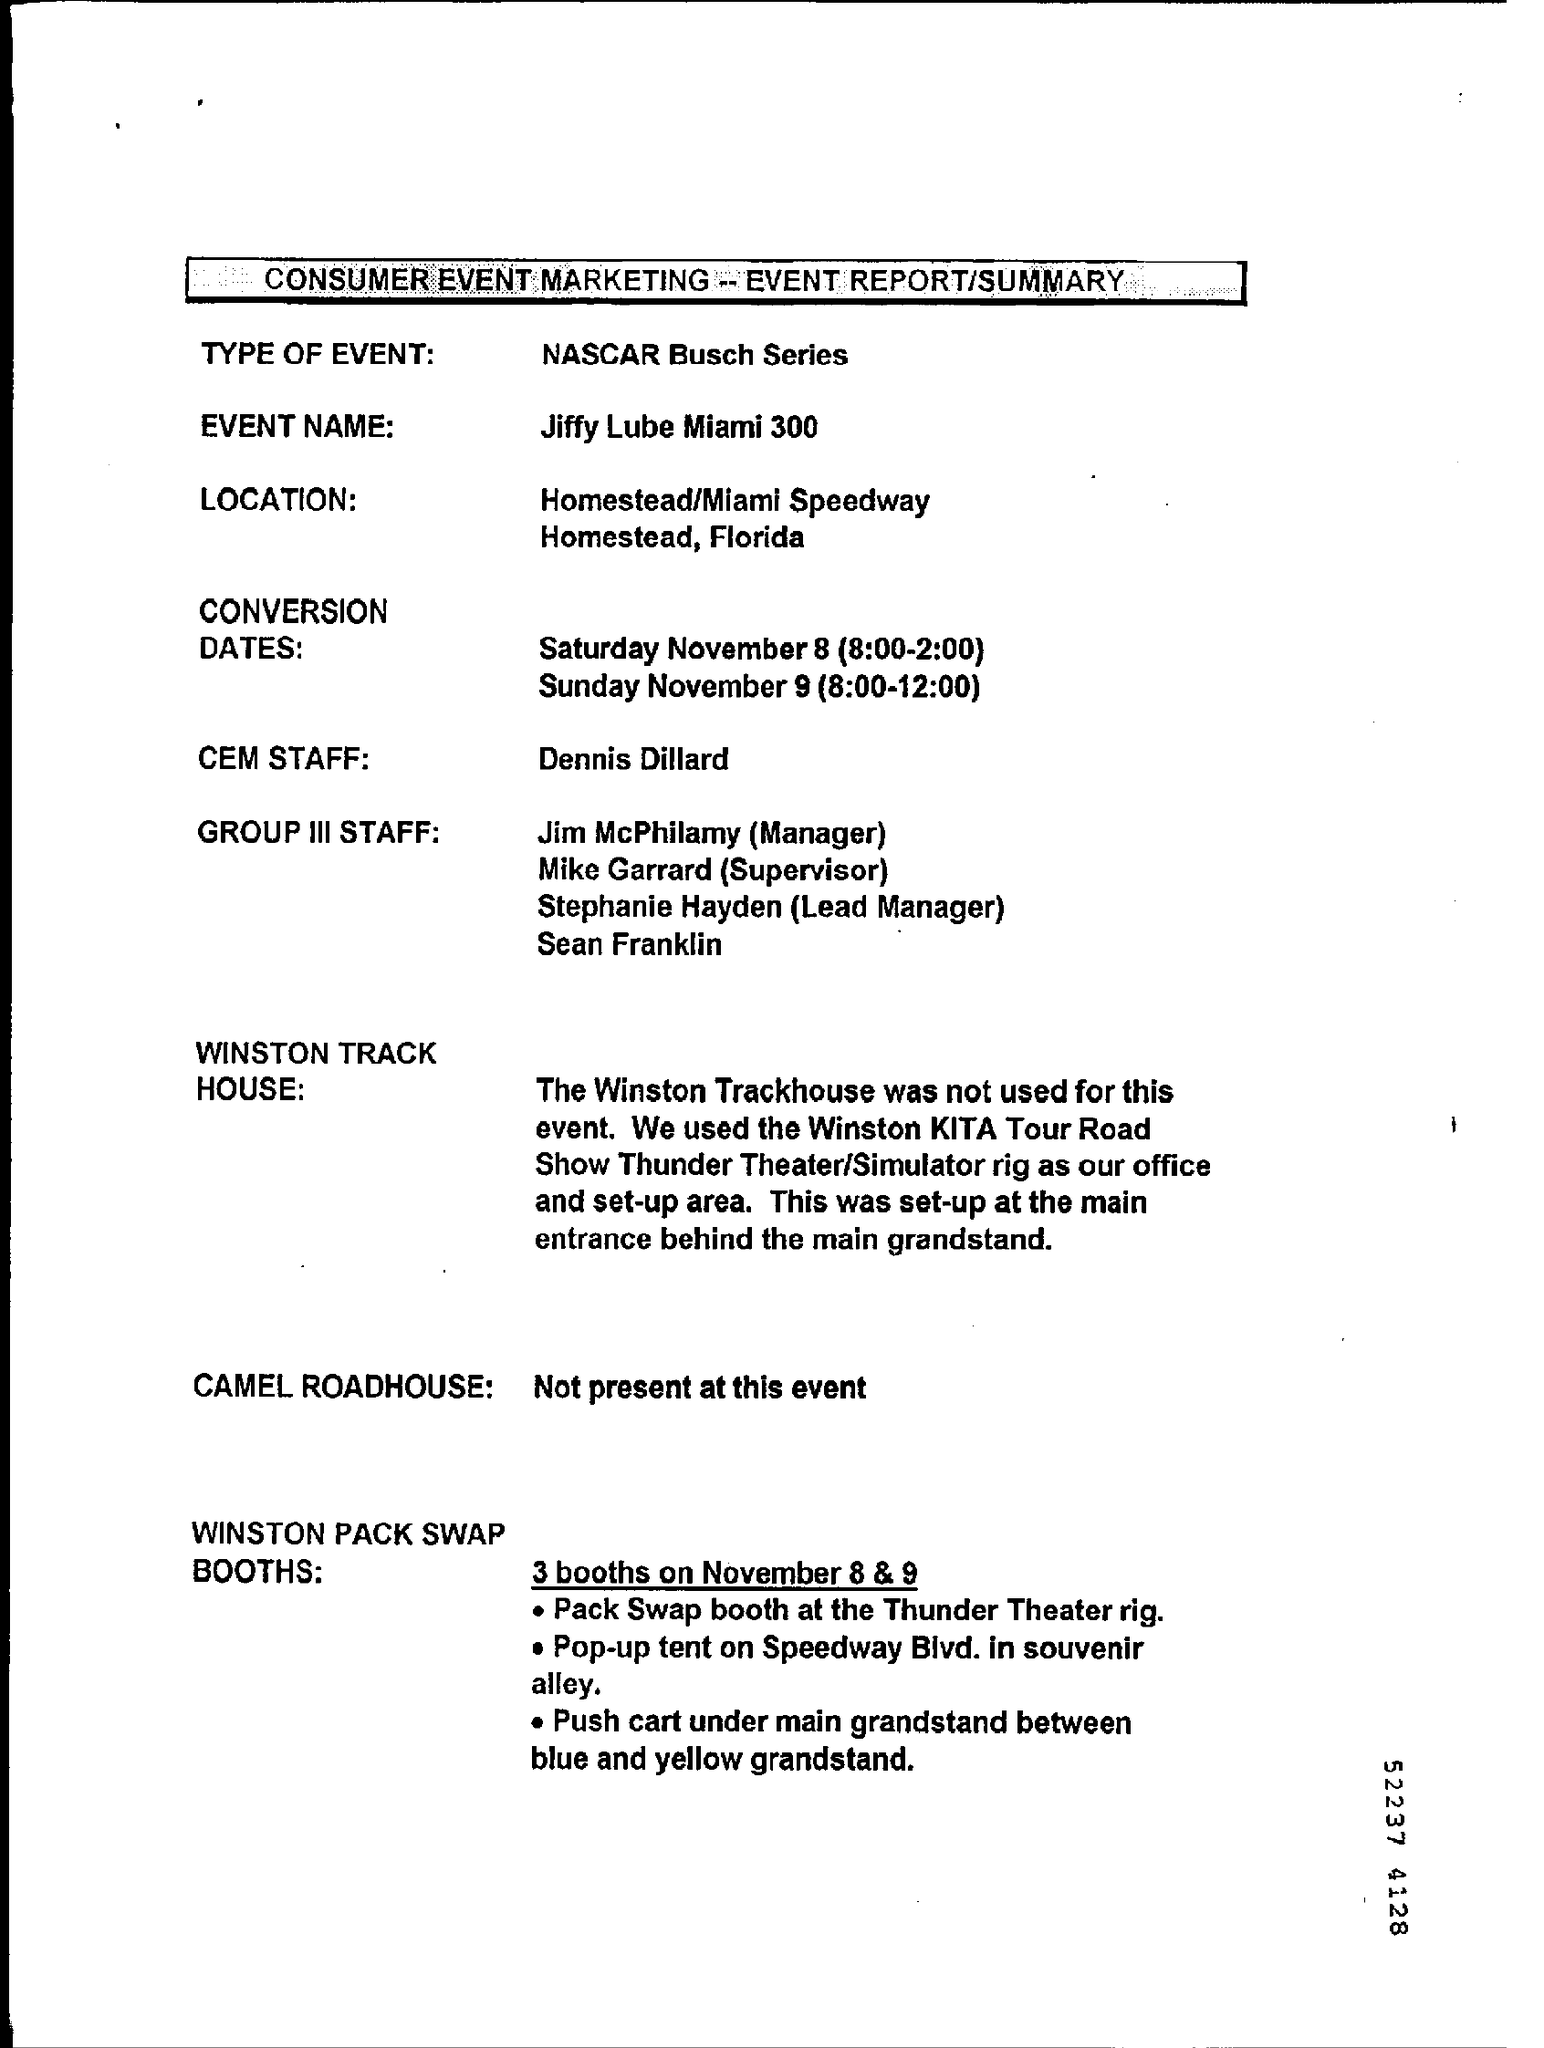What is time of programme on November 8?
Offer a terse response. 8:00-2:00. What is time of programme on November 9?
Give a very brief answer. 8:00-12:00. What is the name of the event?
Provide a succinct answer. JIffy Lube Miami 300. What is mentioned as type of the event?
Offer a very short reply. Nascar Busch Series. 